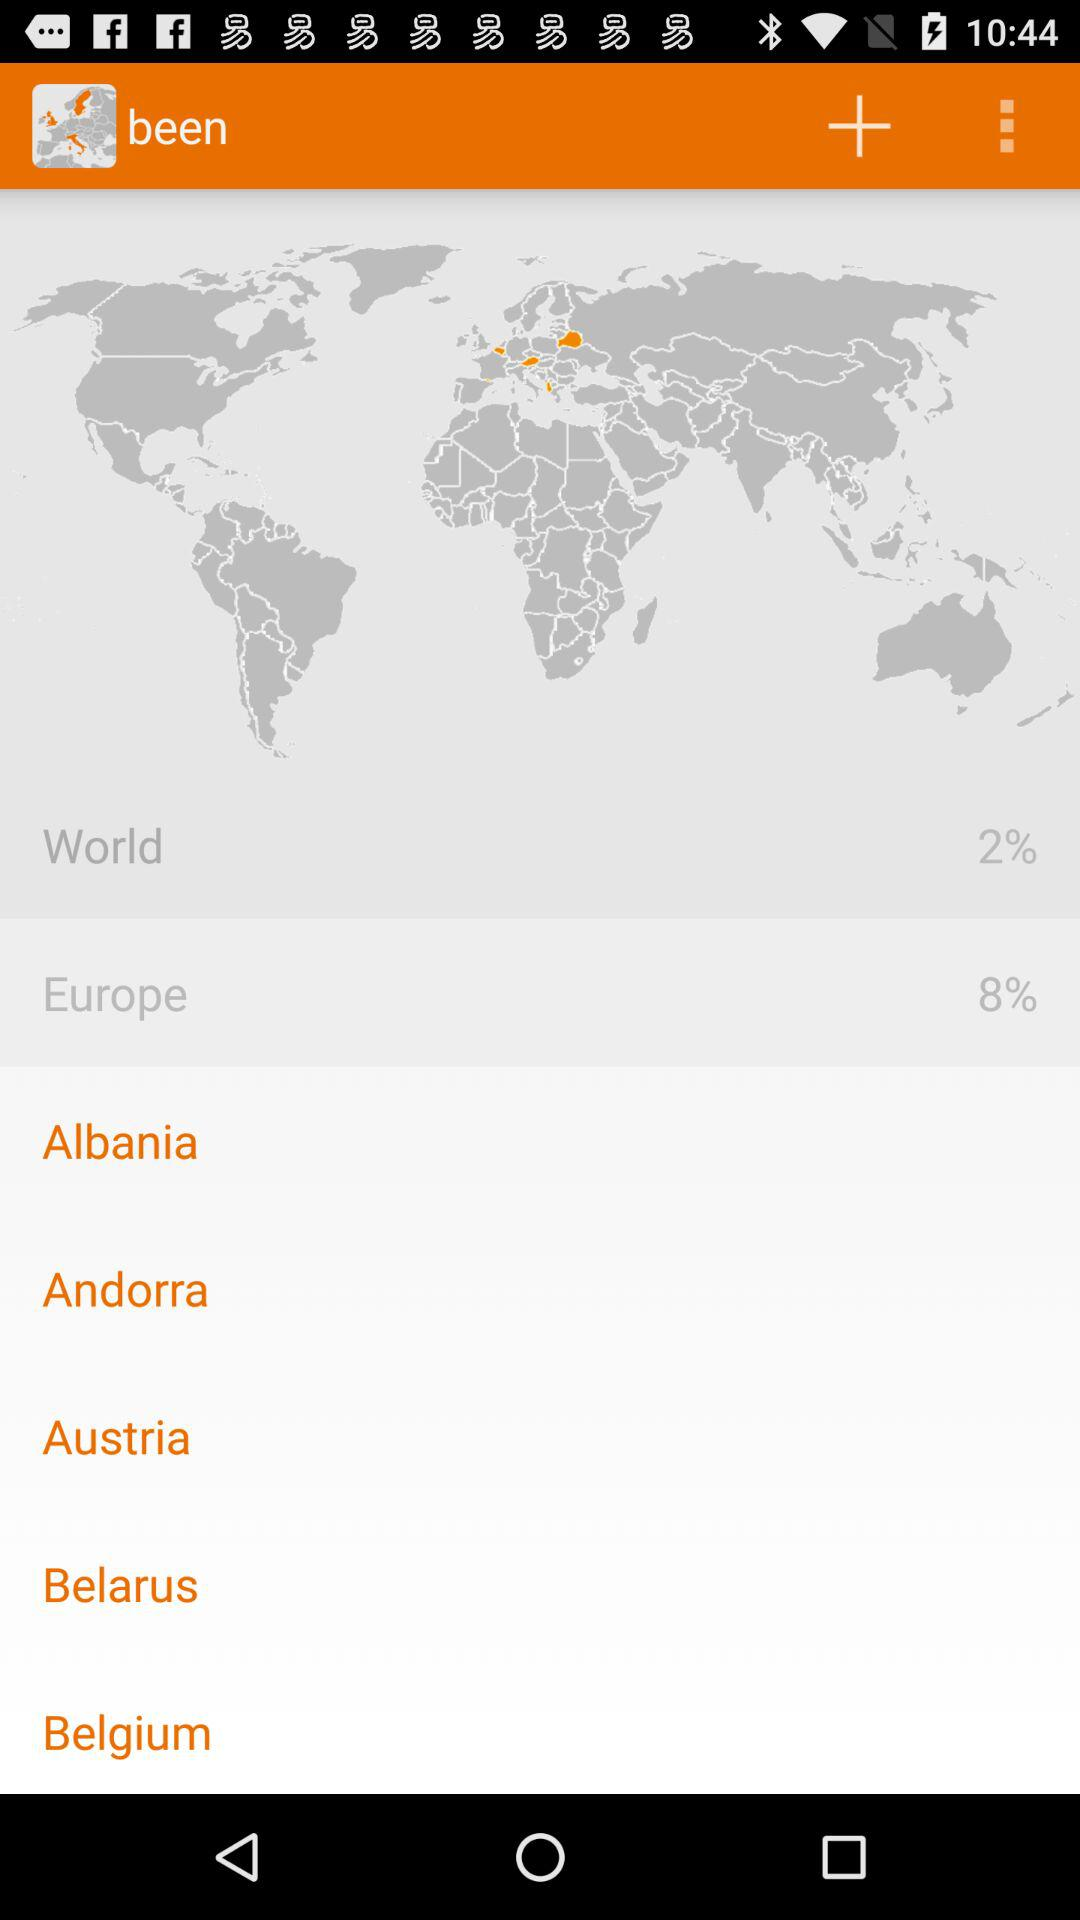What is the percentage shown in Europe? The percentage shown in Europe is 8%. 